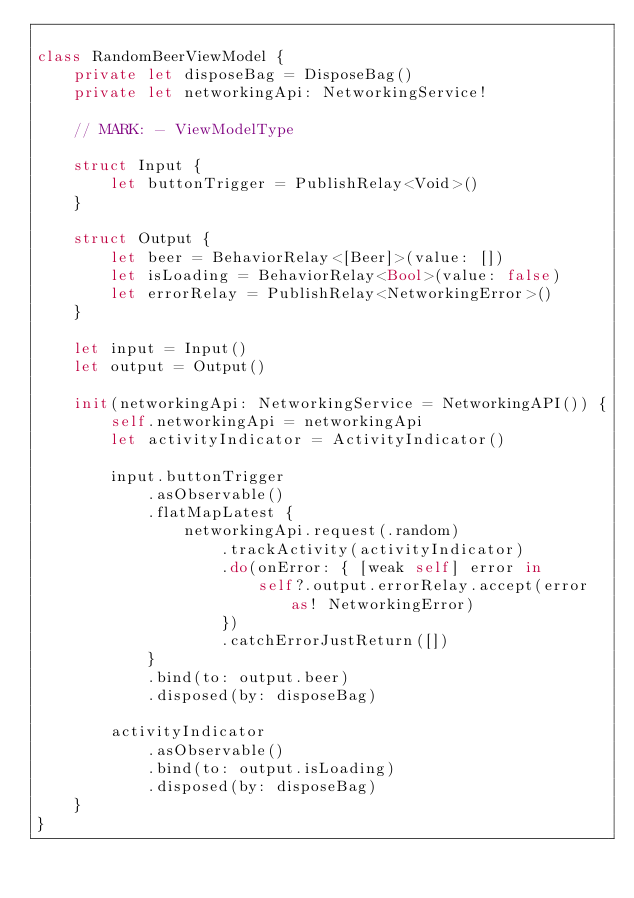Convert code to text. <code><loc_0><loc_0><loc_500><loc_500><_Swift_>
class RandomBeerViewModel {
    private let disposeBag = DisposeBag()
    private let networkingApi: NetworkingService!
    
    // MARK: - ViewModelType
    
    struct Input {
        let buttonTrigger = PublishRelay<Void>()
    }
    
    struct Output {
        let beer = BehaviorRelay<[Beer]>(value: [])
        let isLoading = BehaviorRelay<Bool>(value: false)
        let errorRelay = PublishRelay<NetworkingError>()
    }
    
    let input = Input()
    let output = Output()
    
    init(networkingApi: NetworkingService = NetworkingAPI()) {
        self.networkingApi = networkingApi
        let activityIndicator = ActivityIndicator()
        
        input.buttonTrigger
            .asObservable()
            .flatMapLatest {
                networkingApi.request(.random)
                    .trackActivity(activityIndicator)
                    .do(onError: { [weak self] error in
                        self?.output.errorRelay.accept(error as! NetworkingError)
                    })
                    .catchErrorJustReturn([])
            }
            .bind(to: output.beer)
            .disposed(by: disposeBag)
        
        activityIndicator
            .asObservable()
            .bind(to: output.isLoading)
            .disposed(by: disposeBag)
    }
}
</code> 